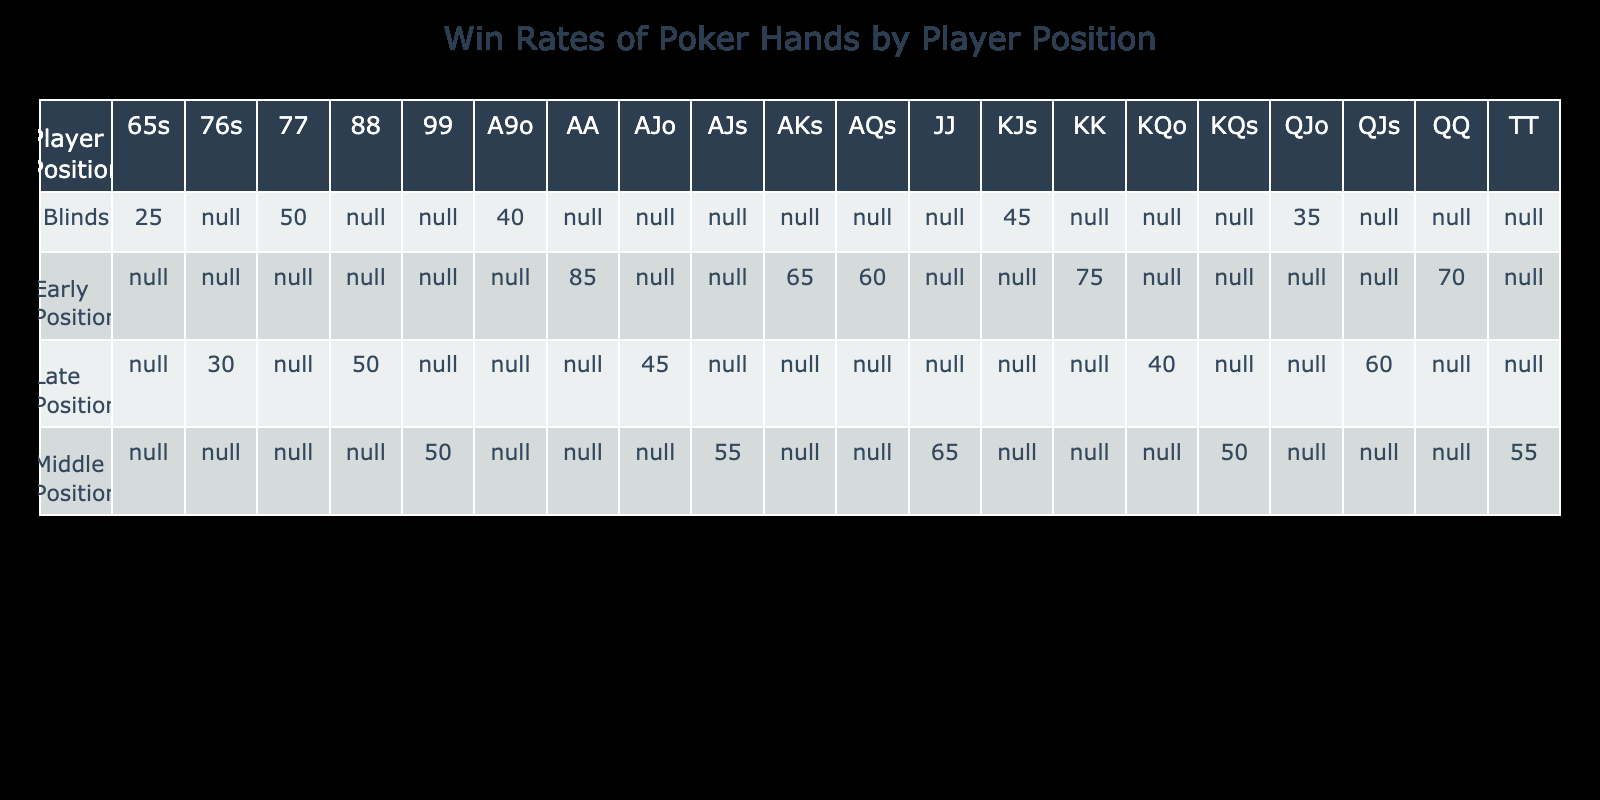What is the win rate for AA in early position? The table shows the win rate for the hand type AA in the early position is specified directly under the column for the hand type. It reads 85% for the combination of 'Early Position' and 'AA'.
Answer: 85% What is the lowest win rate for hands in late position? Observing the win rates for the late position, the values are 50, 45, 40, 30, and 60. The lowest among these is 30%, which corresponds to the hand type '76s'.
Answer: 30% What is the average win rate for hands in middle position? For middle position, the win rates are 65%, 55%, 50%, 55%, and 50%. To find the average, we add these values: 65 + 55 + 50 + 55 + 50 = 275. Dividing by the number of hands (5), we get 275/5 = 55%.
Answer: 55% Is the win rate for KJs in the blinds higher or lower than the win rate for A9o? Looking at the entries, the win rate for KJs in the blinds is 45%, while the win rate for A9o in the blinds is 40%. Since 45% is higher than 40%, the answer is that KJs has a higher win rate.
Answer: Higher Which player position has the highest win rate overall? To determine this, we compare the highest win rates in each position: Early position has 85% (AA), Middle position has 65% (JJ), Late position has 60% (QJs), and Blinds has 50% (77). The overall highest value is 85% in Early position.
Answer: Early Position What is the difference in win rates between KK and AQo for the respective positions? KK in early position has a win rate of 75%, while AQo is not listed, indicating it has no win rate that can be compared. Therefore, we can conclude that there is no direct comparison.
Answer: Not applicable What is the win rate for hands in the blinds that are lower than 40%? Referring to the blinds section, the win rates below 40% are for 65s (25%) and QJo (35%). Overall, there are two hands with win rates lower than 40%.
Answer: 2 hands If a player has JJ in middle position and KQo in late position, what is their total win rate? JJ in middle position has a win rate of 65%, and KQo in late position has a win rate of 40%. Adding these two values together gives us 65% + 40% = 105%.
Answer: 105% 